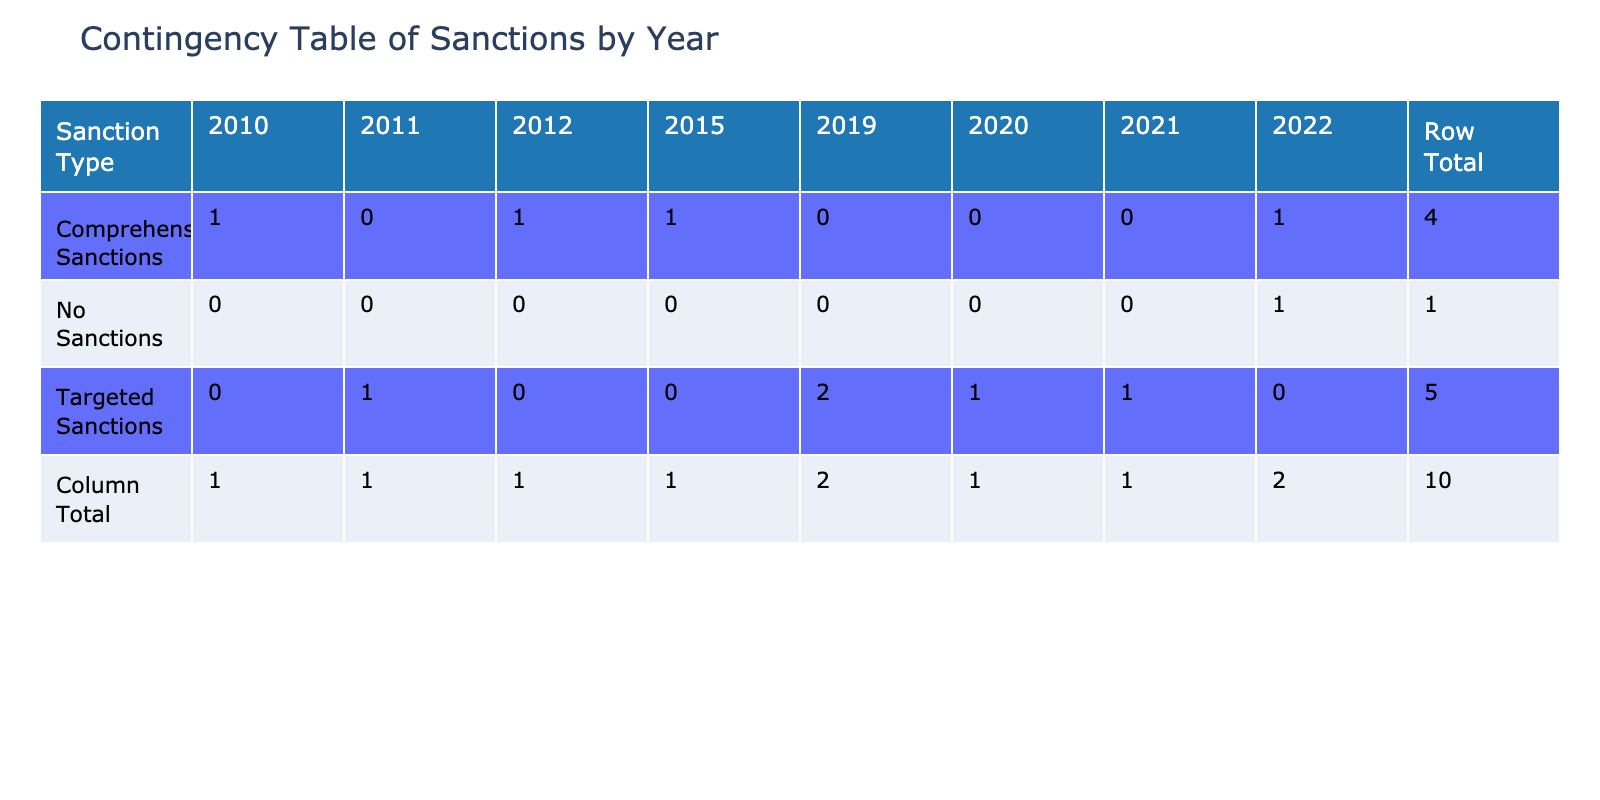What is the oil export revenue of Nigeria in 2019? In the table, the row for Nigeria shows that the oil export revenue for Nigeria in 2019 is listed as 35 billion USD.
Answer: 35 billion USD Which country received the least foreign aid in the year 2022? By looking at the 2022 column in the foreign aid received section, Kuwait has the lowest value at 0.6 billion USD.
Answer: Kuwait What is the total foreign aid received by Iran and Iraq combined? To find the total foreign aid for Iran (1.5 billion USD) and Iraq (2.0 billion USD), we add both amounts together: 1.5 + 2.0 = 3.5 billion USD.
Answer: 3.5 billion USD Is it true that North Korea received more foreign aid than Libya? By comparing foreign aid amounts in the table, North Korea received 0.1 billion USD, while Libya received 0.3 billion USD. Since 0.1 is less than 0.3, this statement is false.
Answer: No What is the average oil export revenue of countries under comprehensive sanctions? The countries under comprehensive sanctions are Iran (24), Russia (80), Sudan (5), and Libya (20). To find the average, we first sum these: 24 + 80 + 5 + 20 = 129 billion USD, and then divide by the number of countries (4): 129 / 4 = 32.25 billion USD.
Answer: 32.25 billion USD How many countries received more than 1 billion USD in foreign aid? The foreign aid values are as follows: Iran (1.5), Venezuela (0.5), Russia (1.2), Iraq (2.0), Sudan (0.8), Libya (0.3), North Korea (0.1), Syria (0.2), Nigeria (3.0), and Kuwait (0.6). The countries that received more than 1 billion USD are Iran, Iraq, and Nigeria, totaling 3 countries.
Answer: 3 countries What country had the highest oil export revenue in the year 2022? Looking at the year 2022 in the oil export revenue section, Russia shows the highest value at 80 billion USD.
Answer: Russia In how many years were targeted sanctions imposed? The years with targeted sanctions in the table are 2011 (Iraq), 2019 (Venezuela and Nigeria), and 2020 (Syria), and 2021 (North Korea). Counting these years gives a total of 4 distinct years.
Answer: 4 years 